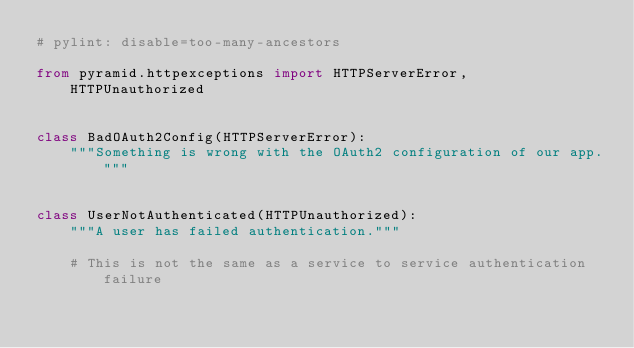<code> <loc_0><loc_0><loc_500><loc_500><_Python_># pylint: disable=too-many-ancestors

from pyramid.httpexceptions import HTTPServerError, HTTPUnauthorized


class BadOAuth2Config(HTTPServerError):
    """Something is wrong with the OAuth2 configuration of our app."""


class UserNotAuthenticated(HTTPUnauthorized):
    """A user has failed authentication."""

    # This is not the same as a service to service authentication failure
</code> 